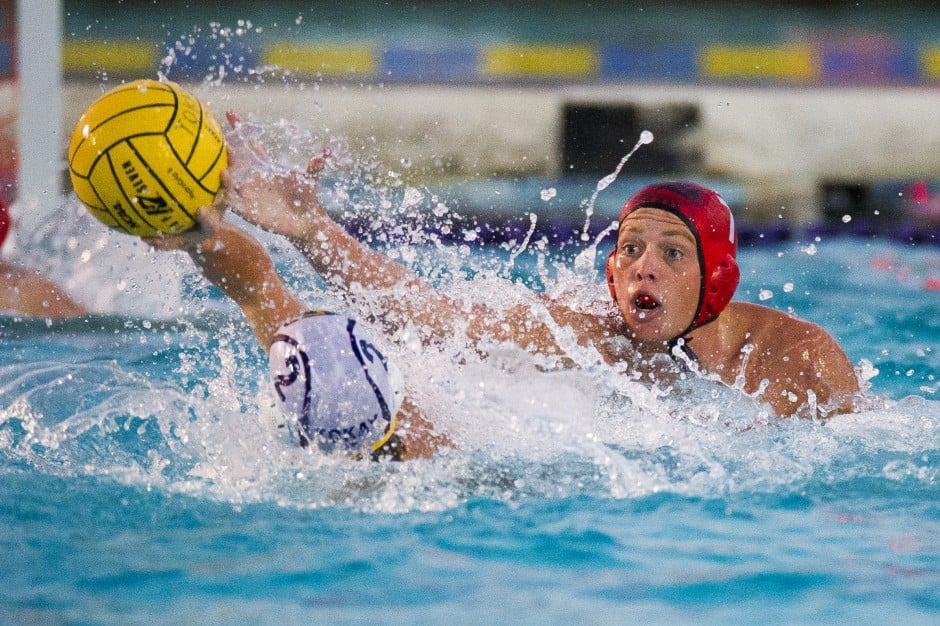Describe the intensity of this water polo match and what might be at stake for the teams involved. The intensity of this water polo match is palpable, with splashes of water and focused expressions highlighting the fierce competition between the two players. The stakes could be incredibly high, such as securing a spot in a championship, maintaining an unbeaten streak, or simply the pride of winning against a rival team. The determination in the eyes of the player in the red cap and the vigor in their reach for the ball underscores the dedication and effort both teams are putting into trying to gain possession and control of the game. What might be going through the minds of these players as they battle for the ball? In the heat of the moment, the player in the red cap likely has a singular focus: secure the ball. Their training and instincts are in overdrive, quickly calculating the best way to intercept the pass and take control for their team. They might be thinking about their next move, how to avoid fouling, and positioning themselves for a clear shot or pass if they gain possession. On the other hand, the player in the white cap could be experiencing a mix of determination and urgency, striving to retain possession while navigating the aggressive challenge from the opponent. Each player is fully immersed, demonstrating quick reflexes and strategic thinking, all under the pressure of the competitive environment. Imagine a scenario where an underwater camera captures the players from beneath. What might it reveal? An underwater camera capturing the scene from beneath would unveil a mesmerizing ballet of athleticism and strategy. Beneath the surface, their legs engage in a synchronized dance of treading water, demonstrating incredible lower body strength. The player's legs move with rapid, powerful scissor kicks to maintain buoyancy and maneuverability. The water ripples with each explosive movement, and you might see the stark contrast between calm and chaos, with moments of stillness before an eruption of effort as they propel themselves upwards. This perspective would also highlight the teamwork involved, with players ready to assist or receive a pass. It emphasizes the unseen effort that contributes to the fierce competition witnessed above the surface. If the ball could talk, what would it say about this moment? If the ball could talk, it might describe an exhilarating ride filled with suspense and anticipation. It would recount the last few moments, having been passed, thrown, and almost caught, sensing the tension between the two players vying for control. It would narrate the speed and force with which it was thrown, the resistance of the water, and now, the imminent clash of hands reaching desperately to seize it. There's a sense of being the central focus of this intense struggle, feeling the pressure from both teams and the quick decision-making that defines this heated instant. The ball could express a sense of excitement, knowing it holds the potential to change the course of the game with whichever hand grasps it next. 